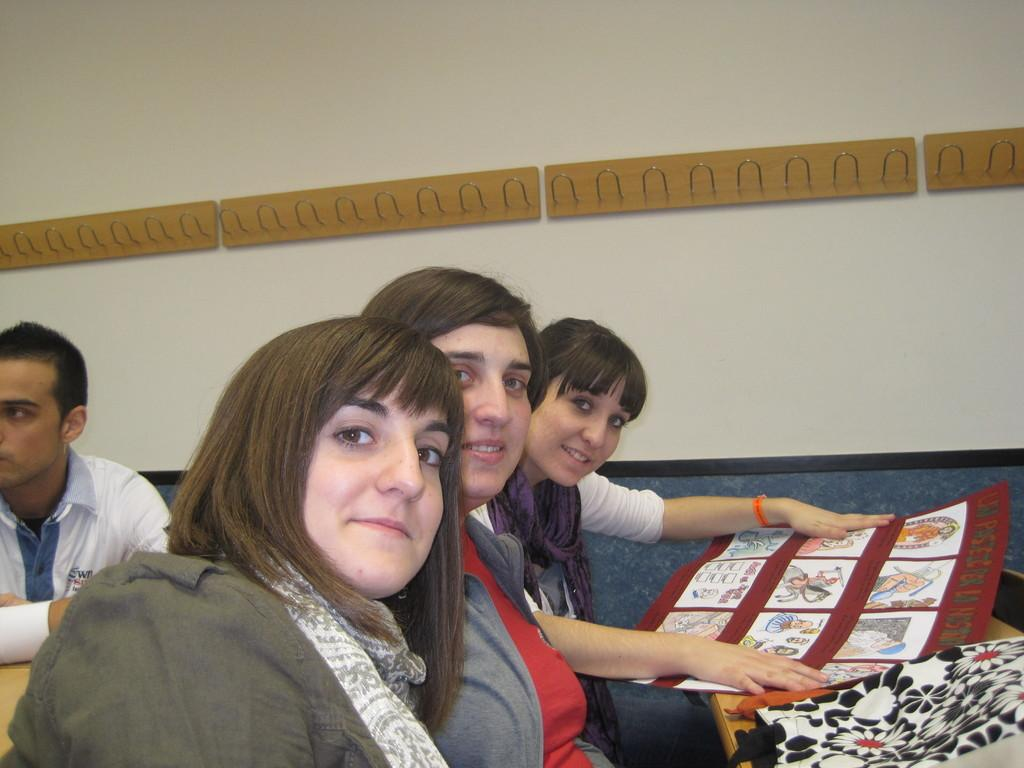How many women are in the image? There are three women in the image. What are the women doing in the image? The women are sitting and smiling. What is on the table in front of the women? There is a bag and a chart on the table. Can you describe the background of the image? There is a man and a wall in the background of the image. Reasoning: Let's think step by step by step in order to produce the conversation. We start by identifying the main subjects in the image, which are the three women. Then, we describe their actions and expressions, as well as the objects present in the image, such as the table, bag, and chart. Finally, we mention the background elements, including the man and the wall. Each question is designed to elicit a specific detail about the image that is known from the provided facts. Absurd Question/Answer: Are there any spiders crawling on the women in the image? There are no spiders visible in the image; the women are sitting and smiling without any spiders present. 